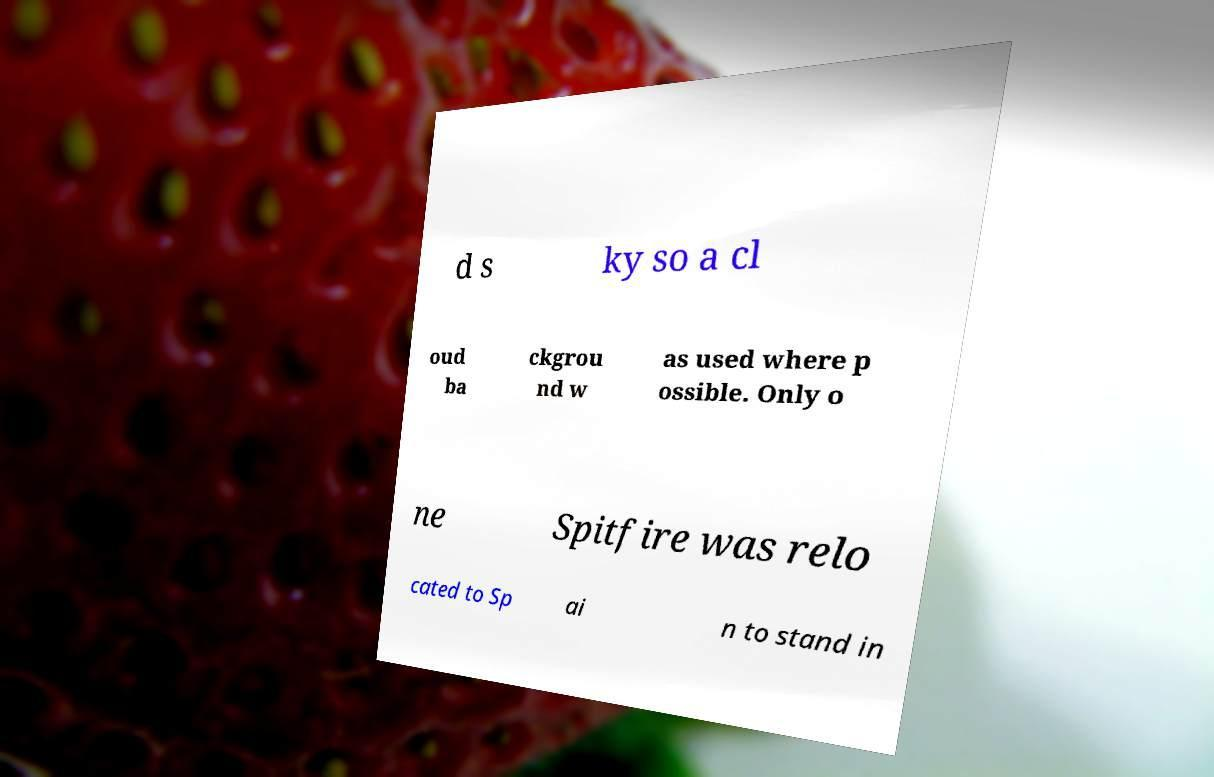Please read and relay the text visible in this image. What does it say? d s ky so a cl oud ba ckgrou nd w as used where p ossible. Only o ne Spitfire was relo cated to Sp ai n to stand in 